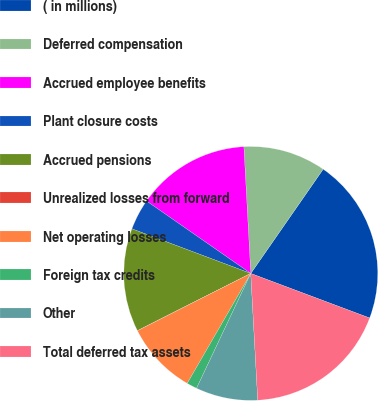<chart> <loc_0><loc_0><loc_500><loc_500><pie_chart><fcel>( in millions)<fcel>Deferred compensation<fcel>Accrued employee benefits<fcel>Plant closure costs<fcel>Accrued pensions<fcel>Unrealized losses from forward<fcel>Net operating losses<fcel>Foreign tax credits<fcel>Other<fcel>Total deferred tax assets<nl><fcel>21.05%<fcel>10.53%<fcel>14.47%<fcel>3.95%<fcel>13.16%<fcel>0.01%<fcel>9.21%<fcel>1.32%<fcel>7.9%<fcel>18.42%<nl></chart> 